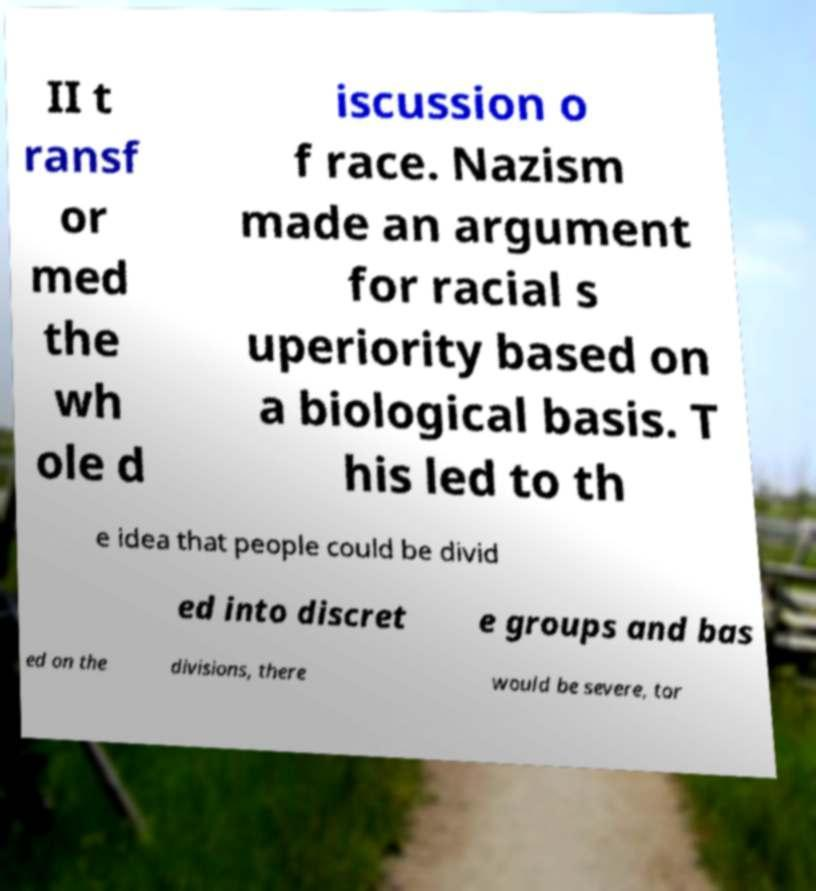For documentation purposes, I need the text within this image transcribed. Could you provide that? II t ransf or med the wh ole d iscussion o f race. Nazism made an argument for racial s uperiority based on a biological basis. T his led to th e idea that people could be divid ed into discret e groups and bas ed on the divisions, there would be severe, tor 